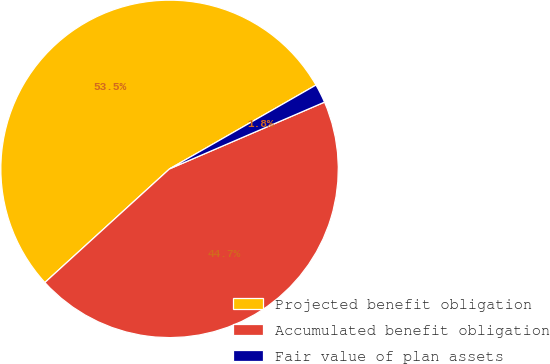<chart> <loc_0><loc_0><loc_500><loc_500><pie_chart><fcel>Projected benefit obligation<fcel>Accumulated benefit obligation<fcel>Fair value of plan assets<nl><fcel>53.49%<fcel>44.71%<fcel>1.8%<nl></chart> 